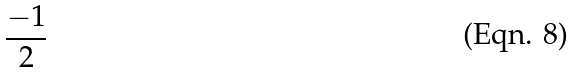<formula> <loc_0><loc_0><loc_500><loc_500>\frac { - 1 } { 2 }</formula> 